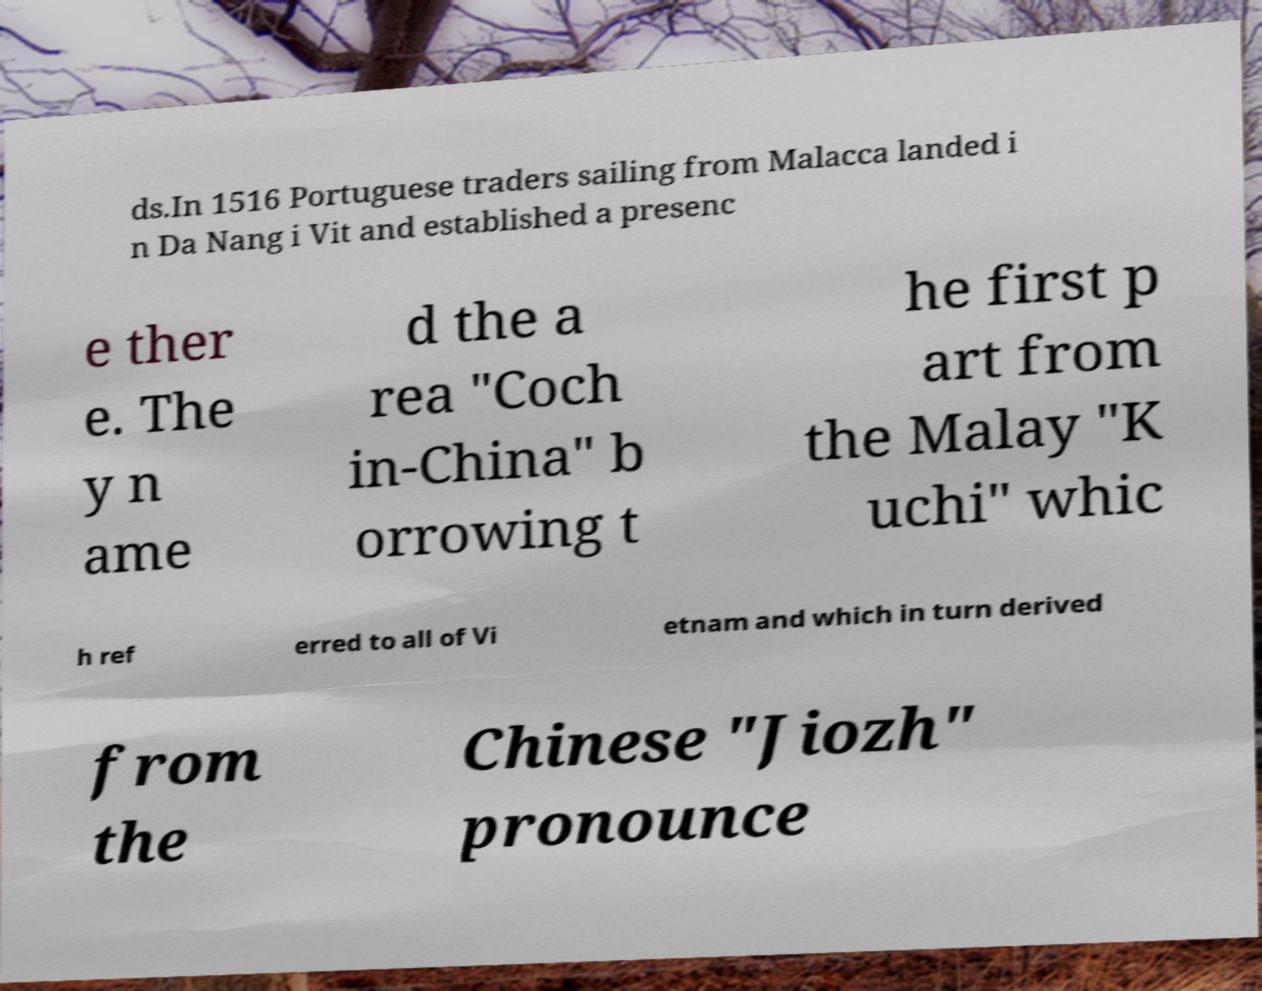I need the written content from this picture converted into text. Can you do that? ds.In 1516 Portuguese traders sailing from Malacca landed i n Da Nang i Vit and established a presenc e ther e. The y n ame d the a rea "Coch in-China" b orrowing t he first p art from the Malay "K uchi" whic h ref erred to all of Vi etnam and which in turn derived from the Chinese "Jiozh" pronounce 